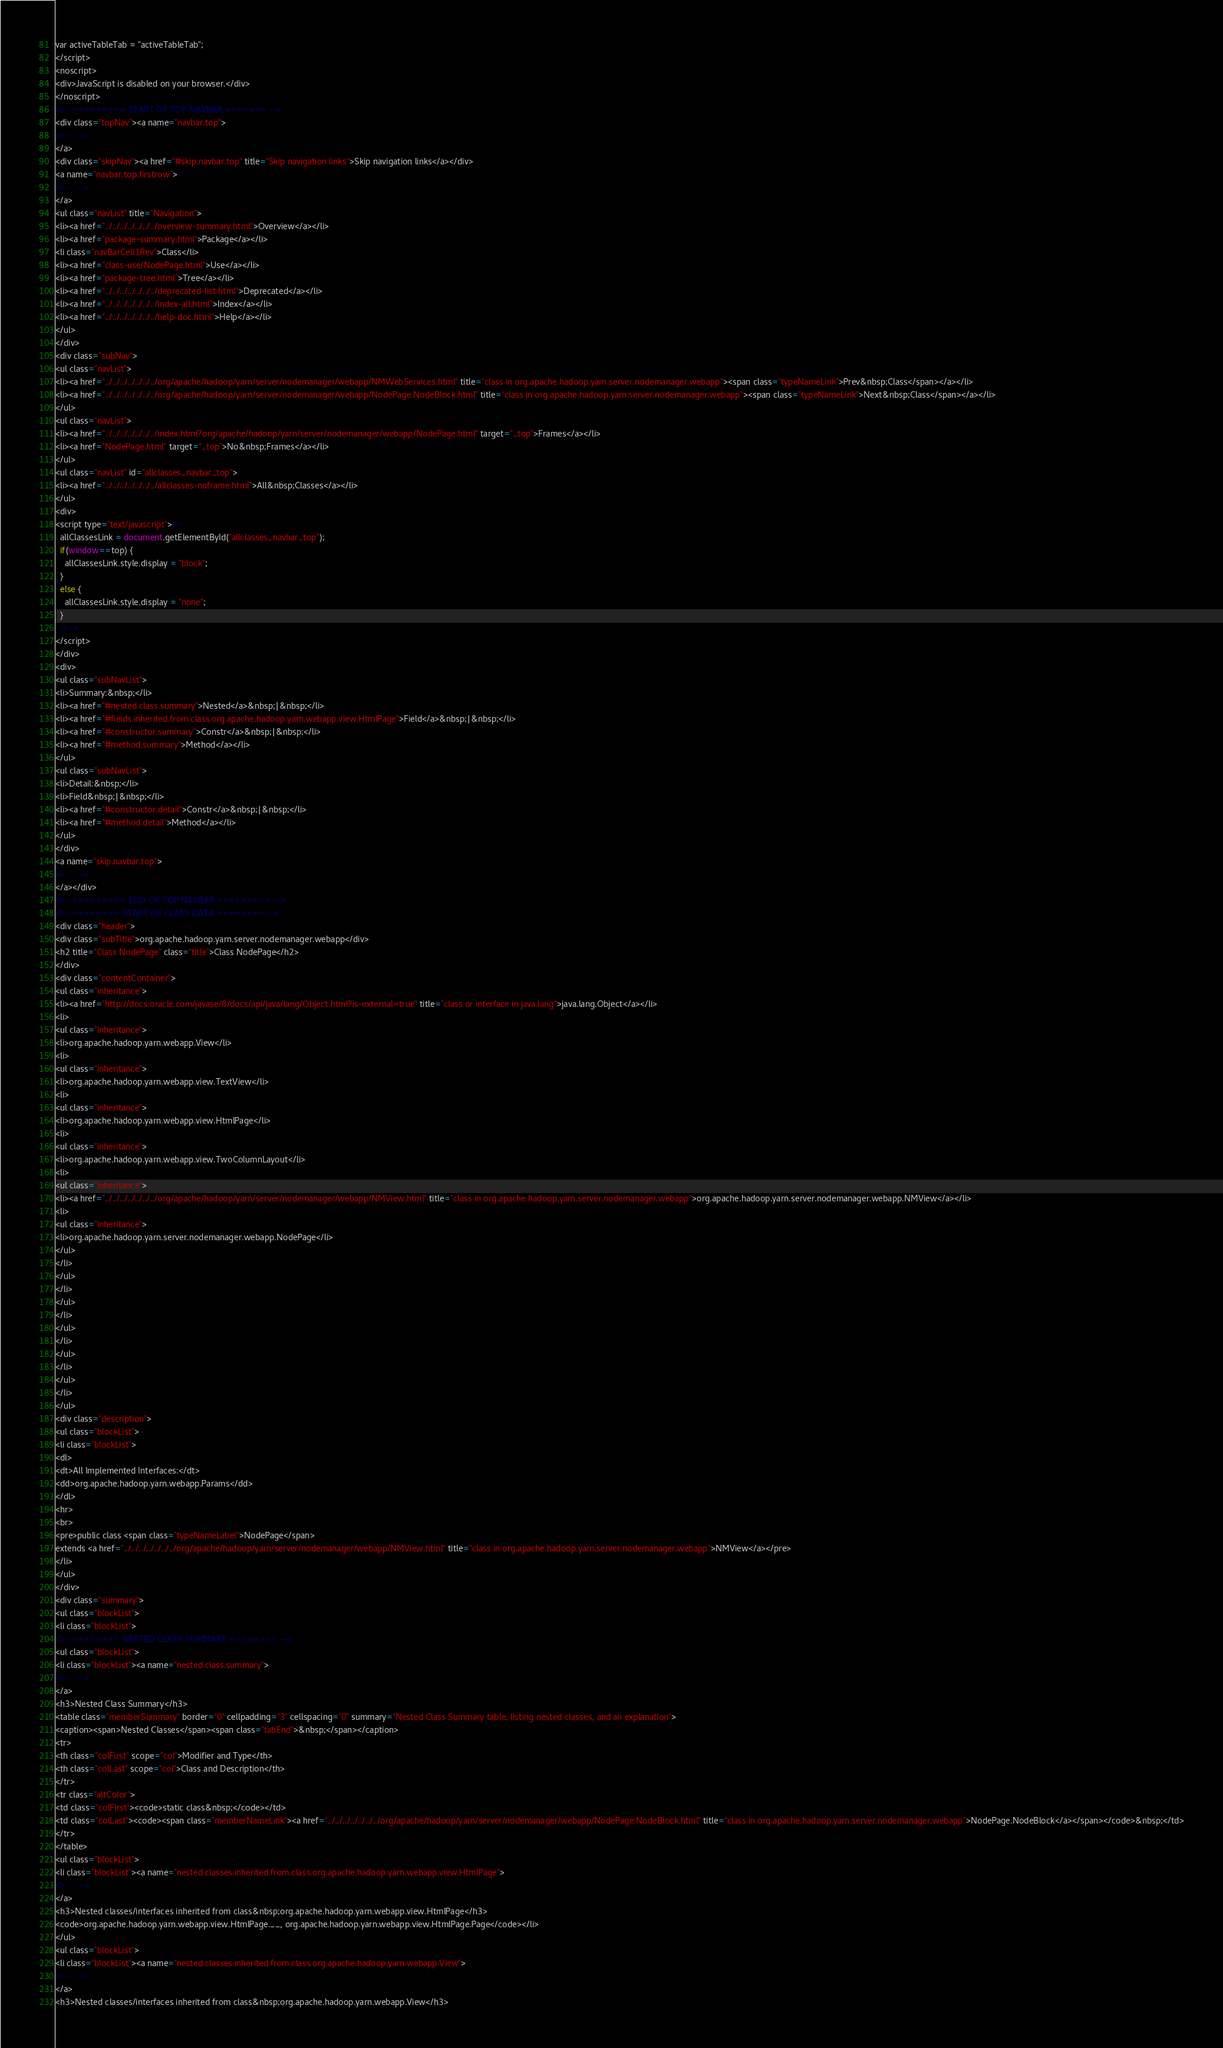Convert code to text. <code><loc_0><loc_0><loc_500><loc_500><_HTML_>var activeTableTab = "activeTableTab";
</script>
<noscript>
<div>JavaScript is disabled on your browser.</div>
</noscript>
<!-- ========= START OF TOP NAVBAR ======= -->
<div class="topNav"><a name="navbar.top">
<!--   -->
</a>
<div class="skipNav"><a href="#skip.navbar.top" title="Skip navigation links">Skip navigation links</a></div>
<a name="navbar.top.firstrow">
<!--   -->
</a>
<ul class="navList" title="Navigation">
<li><a href="../../../../../../../overview-summary.html">Overview</a></li>
<li><a href="package-summary.html">Package</a></li>
<li class="navBarCell1Rev">Class</li>
<li><a href="class-use/NodePage.html">Use</a></li>
<li><a href="package-tree.html">Tree</a></li>
<li><a href="../../../../../../../deprecated-list.html">Deprecated</a></li>
<li><a href="../../../../../../../index-all.html">Index</a></li>
<li><a href="../../../../../../../help-doc.html">Help</a></li>
</ul>
</div>
<div class="subNav">
<ul class="navList">
<li><a href="../../../../../../../org/apache/hadoop/yarn/server/nodemanager/webapp/NMWebServices.html" title="class in org.apache.hadoop.yarn.server.nodemanager.webapp"><span class="typeNameLink">Prev&nbsp;Class</span></a></li>
<li><a href="../../../../../../../org/apache/hadoop/yarn/server/nodemanager/webapp/NodePage.NodeBlock.html" title="class in org.apache.hadoop.yarn.server.nodemanager.webapp"><span class="typeNameLink">Next&nbsp;Class</span></a></li>
</ul>
<ul class="navList">
<li><a href="../../../../../../../index.html?org/apache/hadoop/yarn/server/nodemanager/webapp/NodePage.html" target="_top">Frames</a></li>
<li><a href="NodePage.html" target="_top">No&nbsp;Frames</a></li>
</ul>
<ul class="navList" id="allclasses_navbar_top">
<li><a href="../../../../../../../allclasses-noframe.html">All&nbsp;Classes</a></li>
</ul>
<div>
<script type="text/javascript"><!--
  allClassesLink = document.getElementById("allclasses_navbar_top");
  if(window==top) {
    allClassesLink.style.display = "block";
  }
  else {
    allClassesLink.style.display = "none";
  }
  //-->
</script>
</div>
<div>
<ul class="subNavList">
<li>Summary:&nbsp;</li>
<li><a href="#nested.class.summary">Nested</a>&nbsp;|&nbsp;</li>
<li><a href="#fields.inherited.from.class.org.apache.hadoop.yarn.webapp.view.HtmlPage">Field</a>&nbsp;|&nbsp;</li>
<li><a href="#constructor.summary">Constr</a>&nbsp;|&nbsp;</li>
<li><a href="#method.summary">Method</a></li>
</ul>
<ul class="subNavList">
<li>Detail:&nbsp;</li>
<li>Field&nbsp;|&nbsp;</li>
<li><a href="#constructor.detail">Constr</a>&nbsp;|&nbsp;</li>
<li><a href="#method.detail">Method</a></li>
</ul>
</div>
<a name="skip.navbar.top">
<!--   -->
</a></div>
<!-- ========= END OF TOP NAVBAR ========= -->
<!-- ======== START OF CLASS DATA ======== -->
<div class="header">
<div class="subTitle">org.apache.hadoop.yarn.server.nodemanager.webapp</div>
<h2 title="Class NodePage" class="title">Class NodePage</h2>
</div>
<div class="contentContainer">
<ul class="inheritance">
<li><a href="http://docs.oracle.com/javase/8/docs/api/java/lang/Object.html?is-external=true" title="class or interface in java.lang">java.lang.Object</a></li>
<li>
<ul class="inheritance">
<li>org.apache.hadoop.yarn.webapp.View</li>
<li>
<ul class="inheritance">
<li>org.apache.hadoop.yarn.webapp.view.TextView</li>
<li>
<ul class="inheritance">
<li>org.apache.hadoop.yarn.webapp.view.HtmlPage</li>
<li>
<ul class="inheritance">
<li>org.apache.hadoop.yarn.webapp.view.TwoColumnLayout</li>
<li>
<ul class="inheritance">
<li><a href="../../../../../../../org/apache/hadoop/yarn/server/nodemanager/webapp/NMView.html" title="class in org.apache.hadoop.yarn.server.nodemanager.webapp">org.apache.hadoop.yarn.server.nodemanager.webapp.NMView</a></li>
<li>
<ul class="inheritance">
<li>org.apache.hadoop.yarn.server.nodemanager.webapp.NodePage</li>
</ul>
</li>
</ul>
</li>
</ul>
</li>
</ul>
</li>
</ul>
</li>
</ul>
</li>
</ul>
<div class="description">
<ul class="blockList">
<li class="blockList">
<dl>
<dt>All Implemented Interfaces:</dt>
<dd>org.apache.hadoop.yarn.webapp.Params</dd>
</dl>
<hr>
<br>
<pre>public class <span class="typeNameLabel">NodePage</span>
extends <a href="../../../../../../../org/apache/hadoop/yarn/server/nodemanager/webapp/NMView.html" title="class in org.apache.hadoop.yarn.server.nodemanager.webapp">NMView</a></pre>
</li>
</ul>
</div>
<div class="summary">
<ul class="blockList">
<li class="blockList">
<!-- ======== NESTED CLASS SUMMARY ======== -->
<ul class="blockList">
<li class="blockList"><a name="nested.class.summary">
<!--   -->
</a>
<h3>Nested Class Summary</h3>
<table class="memberSummary" border="0" cellpadding="3" cellspacing="0" summary="Nested Class Summary table, listing nested classes, and an explanation">
<caption><span>Nested Classes</span><span class="tabEnd">&nbsp;</span></caption>
<tr>
<th class="colFirst" scope="col">Modifier and Type</th>
<th class="colLast" scope="col">Class and Description</th>
</tr>
<tr class="altColor">
<td class="colFirst"><code>static class&nbsp;</code></td>
<td class="colLast"><code><span class="memberNameLink"><a href="../../../../../../../org/apache/hadoop/yarn/server/nodemanager/webapp/NodePage.NodeBlock.html" title="class in org.apache.hadoop.yarn.server.nodemanager.webapp">NodePage.NodeBlock</a></span></code>&nbsp;</td>
</tr>
</table>
<ul class="blockList">
<li class="blockList"><a name="nested.classes.inherited.from.class.org.apache.hadoop.yarn.webapp.view.HtmlPage">
<!--   -->
</a>
<h3>Nested classes/interfaces inherited from class&nbsp;org.apache.hadoop.yarn.webapp.view.HtmlPage</h3>
<code>org.apache.hadoop.yarn.webapp.view.HtmlPage.__, org.apache.hadoop.yarn.webapp.view.HtmlPage.Page</code></li>
</ul>
<ul class="blockList">
<li class="blockList"><a name="nested.classes.inherited.from.class.org.apache.hadoop.yarn.webapp.View">
<!--   -->
</a>
<h3>Nested classes/interfaces inherited from class&nbsp;org.apache.hadoop.yarn.webapp.View</h3></code> 